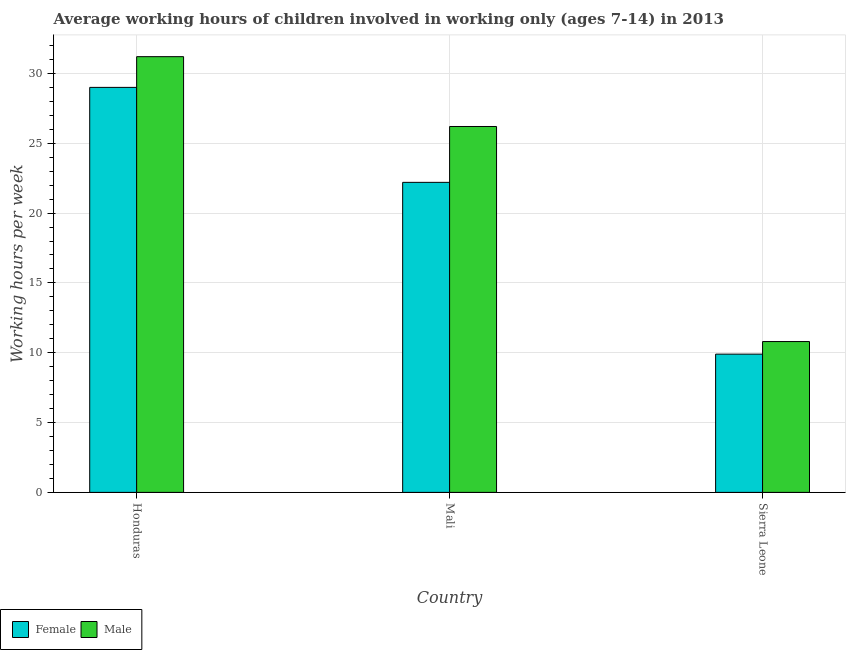How many different coloured bars are there?
Provide a succinct answer. 2. Are the number of bars per tick equal to the number of legend labels?
Give a very brief answer. Yes. Are the number of bars on each tick of the X-axis equal?
Offer a very short reply. Yes. What is the label of the 1st group of bars from the left?
Your answer should be compact. Honduras. What is the average working hour of male children in Mali?
Ensure brevity in your answer.  26.2. Across all countries, what is the maximum average working hour of male children?
Ensure brevity in your answer.  31.2. In which country was the average working hour of male children maximum?
Keep it short and to the point. Honduras. In which country was the average working hour of female children minimum?
Keep it short and to the point. Sierra Leone. What is the total average working hour of male children in the graph?
Provide a short and direct response. 68.2. What is the difference between the average working hour of male children in Honduras and that in Mali?
Make the answer very short. 5. What is the difference between the average working hour of female children in Sierra Leone and the average working hour of male children in Honduras?
Provide a short and direct response. -21.3. What is the average average working hour of male children per country?
Provide a short and direct response. 22.73. What is the difference between the average working hour of female children and average working hour of male children in Mali?
Give a very brief answer. -4. What is the ratio of the average working hour of male children in Honduras to that in Sierra Leone?
Your answer should be very brief. 2.89. Is the average working hour of female children in Honduras less than that in Mali?
Keep it short and to the point. No. Is the difference between the average working hour of female children in Honduras and Sierra Leone greater than the difference between the average working hour of male children in Honduras and Sierra Leone?
Offer a very short reply. No. What is the difference between the highest and the second highest average working hour of female children?
Make the answer very short. 6.8. Is the sum of the average working hour of male children in Honduras and Sierra Leone greater than the maximum average working hour of female children across all countries?
Offer a terse response. Yes. How many bars are there?
Make the answer very short. 6. Does the graph contain grids?
Ensure brevity in your answer.  Yes. Where does the legend appear in the graph?
Your response must be concise. Bottom left. How many legend labels are there?
Provide a succinct answer. 2. What is the title of the graph?
Offer a terse response. Average working hours of children involved in working only (ages 7-14) in 2013. What is the label or title of the X-axis?
Provide a succinct answer. Country. What is the label or title of the Y-axis?
Provide a succinct answer. Working hours per week. What is the Working hours per week in Female in Honduras?
Offer a very short reply. 29. What is the Working hours per week in Male in Honduras?
Give a very brief answer. 31.2. What is the Working hours per week of Male in Mali?
Keep it short and to the point. 26.2. What is the Working hours per week in Male in Sierra Leone?
Ensure brevity in your answer.  10.8. Across all countries, what is the maximum Working hours per week in Female?
Keep it short and to the point. 29. Across all countries, what is the maximum Working hours per week in Male?
Keep it short and to the point. 31.2. Across all countries, what is the minimum Working hours per week of Female?
Ensure brevity in your answer.  9.9. Across all countries, what is the minimum Working hours per week of Male?
Ensure brevity in your answer.  10.8. What is the total Working hours per week in Female in the graph?
Keep it short and to the point. 61.1. What is the total Working hours per week in Male in the graph?
Offer a very short reply. 68.2. What is the difference between the Working hours per week in Female in Honduras and that in Sierra Leone?
Ensure brevity in your answer.  19.1. What is the difference between the Working hours per week of Male in Honduras and that in Sierra Leone?
Make the answer very short. 20.4. What is the difference between the Working hours per week in Male in Mali and that in Sierra Leone?
Provide a succinct answer. 15.4. What is the difference between the Working hours per week of Female in Honduras and the Working hours per week of Male in Sierra Leone?
Ensure brevity in your answer.  18.2. What is the difference between the Working hours per week in Female in Mali and the Working hours per week in Male in Sierra Leone?
Your answer should be very brief. 11.4. What is the average Working hours per week in Female per country?
Your answer should be very brief. 20.37. What is the average Working hours per week in Male per country?
Give a very brief answer. 22.73. What is the difference between the Working hours per week in Female and Working hours per week in Male in Mali?
Offer a terse response. -4. What is the difference between the Working hours per week in Female and Working hours per week in Male in Sierra Leone?
Ensure brevity in your answer.  -0.9. What is the ratio of the Working hours per week in Female in Honduras to that in Mali?
Give a very brief answer. 1.31. What is the ratio of the Working hours per week in Male in Honduras to that in Mali?
Offer a very short reply. 1.19. What is the ratio of the Working hours per week in Female in Honduras to that in Sierra Leone?
Ensure brevity in your answer.  2.93. What is the ratio of the Working hours per week of Male in Honduras to that in Sierra Leone?
Provide a short and direct response. 2.89. What is the ratio of the Working hours per week in Female in Mali to that in Sierra Leone?
Your answer should be compact. 2.24. What is the ratio of the Working hours per week of Male in Mali to that in Sierra Leone?
Your answer should be very brief. 2.43. What is the difference between the highest and the second highest Working hours per week in Female?
Make the answer very short. 6.8. What is the difference between the highest and the lowest Working hours per week of Female?
Keep it short and to the point. 19.1. What is the difference between the highest and the lowest Working hours per week of Male?
Ensure brevity in your answer.  20.4. 